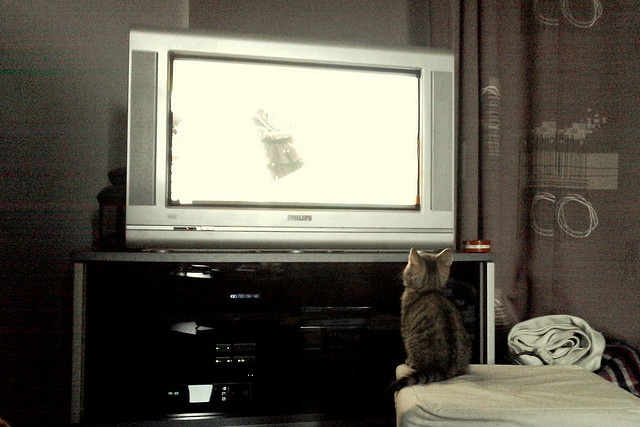Describe the objects in this image and their specific colors. I can see tv in gray, beige, and darkgray tones, bed in gray, tan, and black tones, cat in gray and black tones, and bowl in gray, maroon, black, and darkgray tones in this image. 